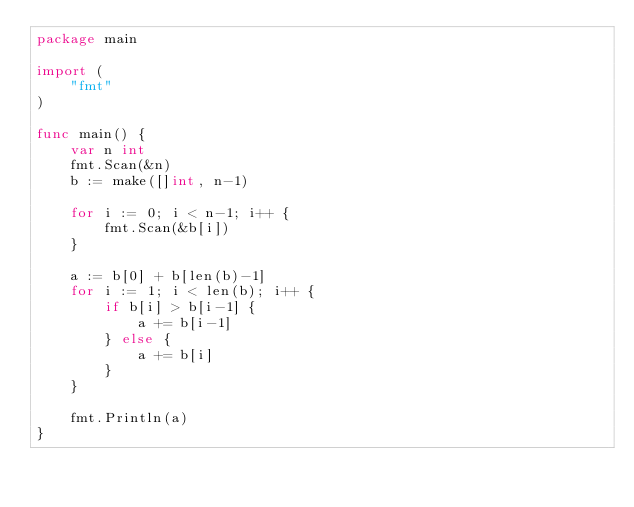Convert code to text. <code><loc_0><loc_0><loc_500><loc_500><_Go_>package main

import (
	"fmt"
)

func main() {
	var n int
	fmt.Scan(&n)
	b := make([]int, n-1)

	for i := 0; i < n-1; i++ {
		fmt.Scan(&b[i])
	}

	a := b[0] + b[len(b)-1]
	for i := 1; i < len(b); i++ {
		if b[i] > b[i-1] {
			a += b[i-1]
		} else {
			a += b[i]
		}
	}

	fmt.Println(a)
}
</code> 